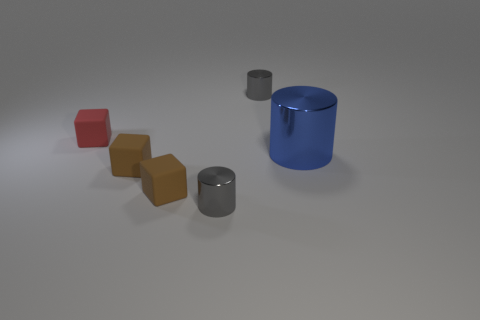What can you infer about the relative sizes of the objects in the image? The objects exhibit a variety of sizes, which are distinguishable due to their proximity and overlapping positions. The blue and gray cylinders appear to be larger, both in height and diameter, compared to the three brown blocks that graduate in size. The red matte block is the smallest in terms of volume, highlighting the diversity in scale within the image. 